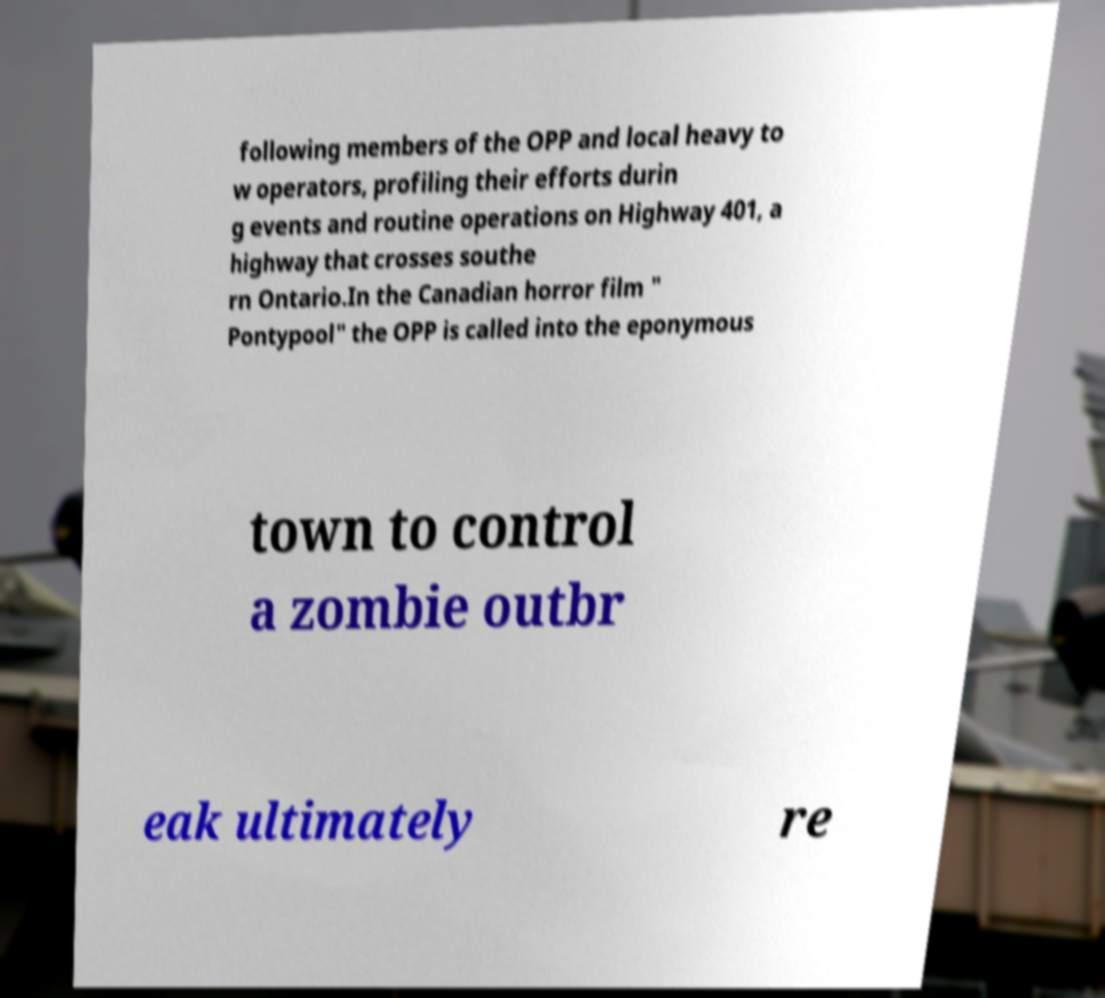Could you assist in decoding the text presented in this image and type it out clearly? following members of the OPP and local heavy to w operators, profiling their efforts durin g events and routine operations on Highway 401, a highway that crosses southe rn Ontario.In the Canadian horror film " Pontypool" the OPP is called into the eponymous town to control a zombie outbr eak ultimately re 